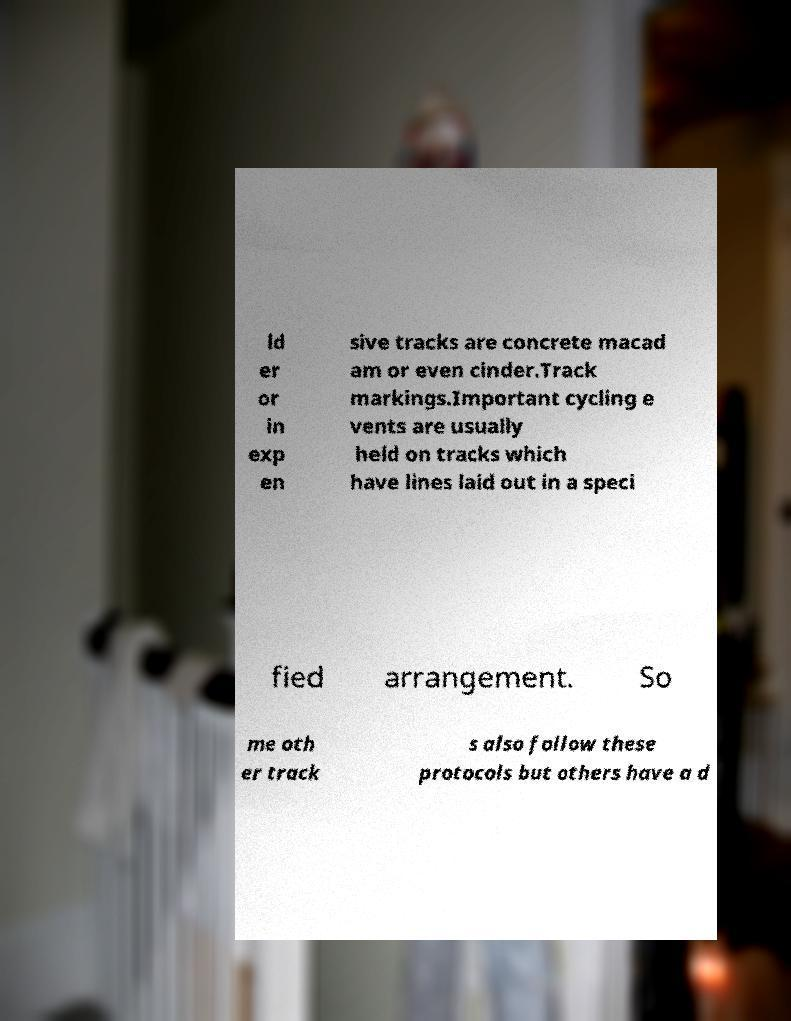I need the written content from this picture converted into text. Can you do that? ld er or in exp en sive tracks are concrete macad am or even cinder.Track markings.Important cycling e vents are usually held on tracks which have lines laid out in a speci fied arrangement. So me oth er track s also follow these protocols but others have a d 